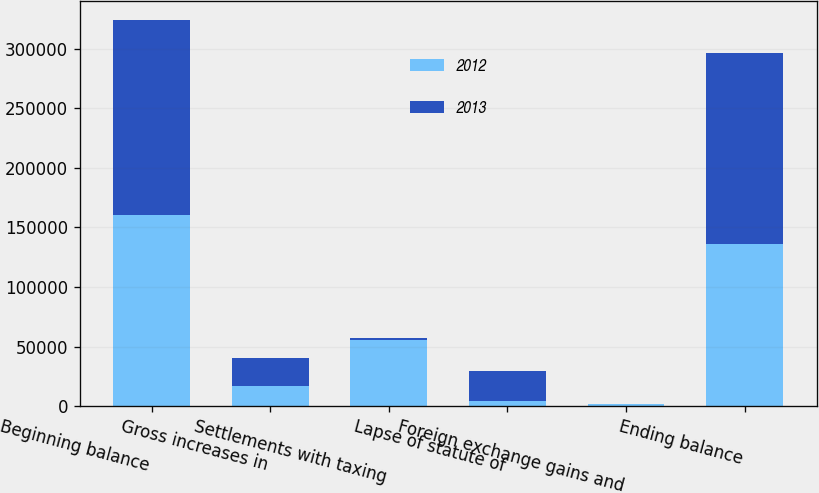Convert chart to OTSL. <chart><loc_0><loc_0><loc_500><loc_500><stacked_bar_chart><ecel><fcel>Beginning balance<fcel>Gross increases in<fcel>Settlements with taxing<fcel>Lapse of statute of<fcel>Foreign exchange gains and<fcel>Ending balance<nl><fcel>2012<fcel>160468<fcel>16777<fcel>55851<fcel>4066<fcel>1474<fcel>136098<nl><fcel>2013<fcel>163607<fcel>23771<fcel>1754<fcel>25387<fcel>807<fcel>160468<nl></chart> 